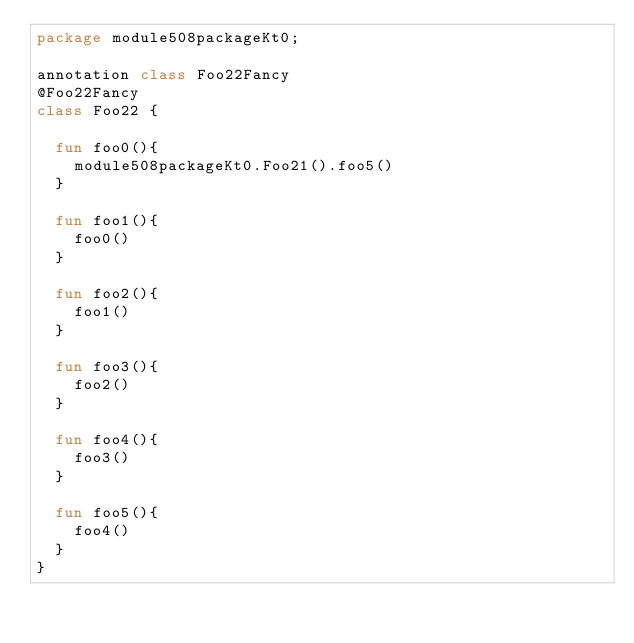<code> <loc_0><loc_0><loc_500><loc_500><_Kotlin_>package module508packageKt0;

annotation class Foo22Fancy
@Foo22Fancy
class Foo22 {

  fun foo0(){
    module508packageKt0.Foo21().foo5()
  }

  fun foo1(){
    foo0()
  }

  fun foo2(){
    foo1()
  }

  fun foo3(){
    foo2()
  }

  fun foo4(){
    foo3()
  }

  fun foo5(){
    foo4()
  }
}</code> 